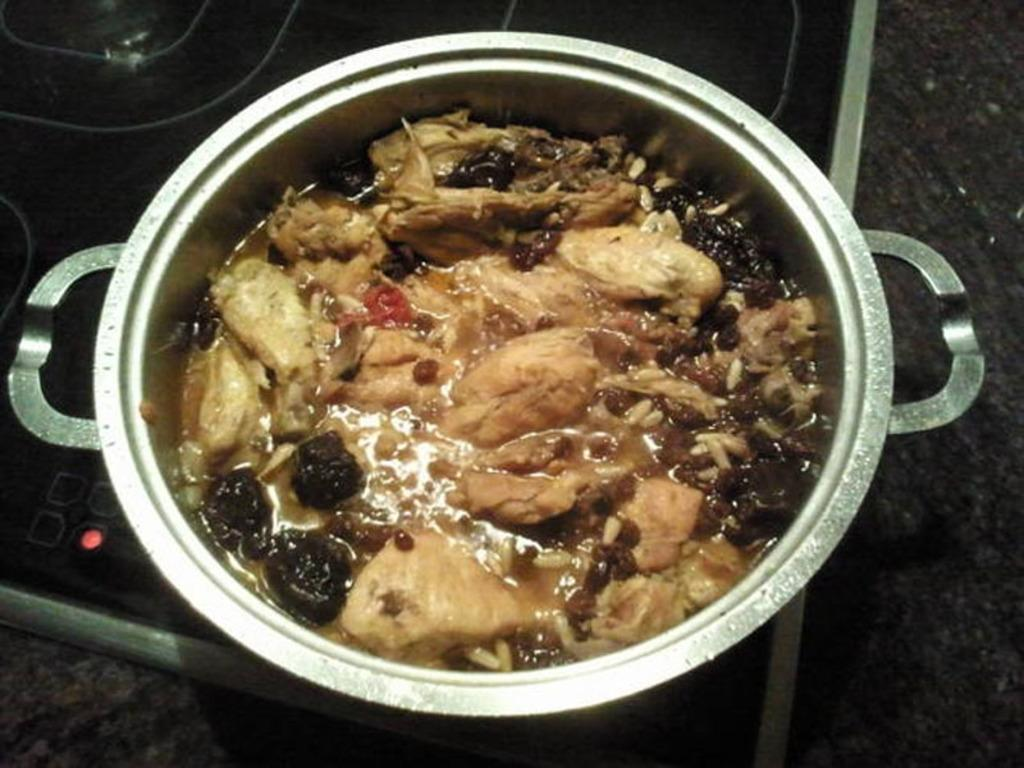What is the main subject of the image? There is a food item in the image. How is the food item contained or stored? The food item is in a steel container. What type of stove is the steel container placed on? The steel container is on an induction stove. What type of comb can be seen in the image? There is no comb present in the image. How many springs are visible in the image? There are no springs visible in the image. 